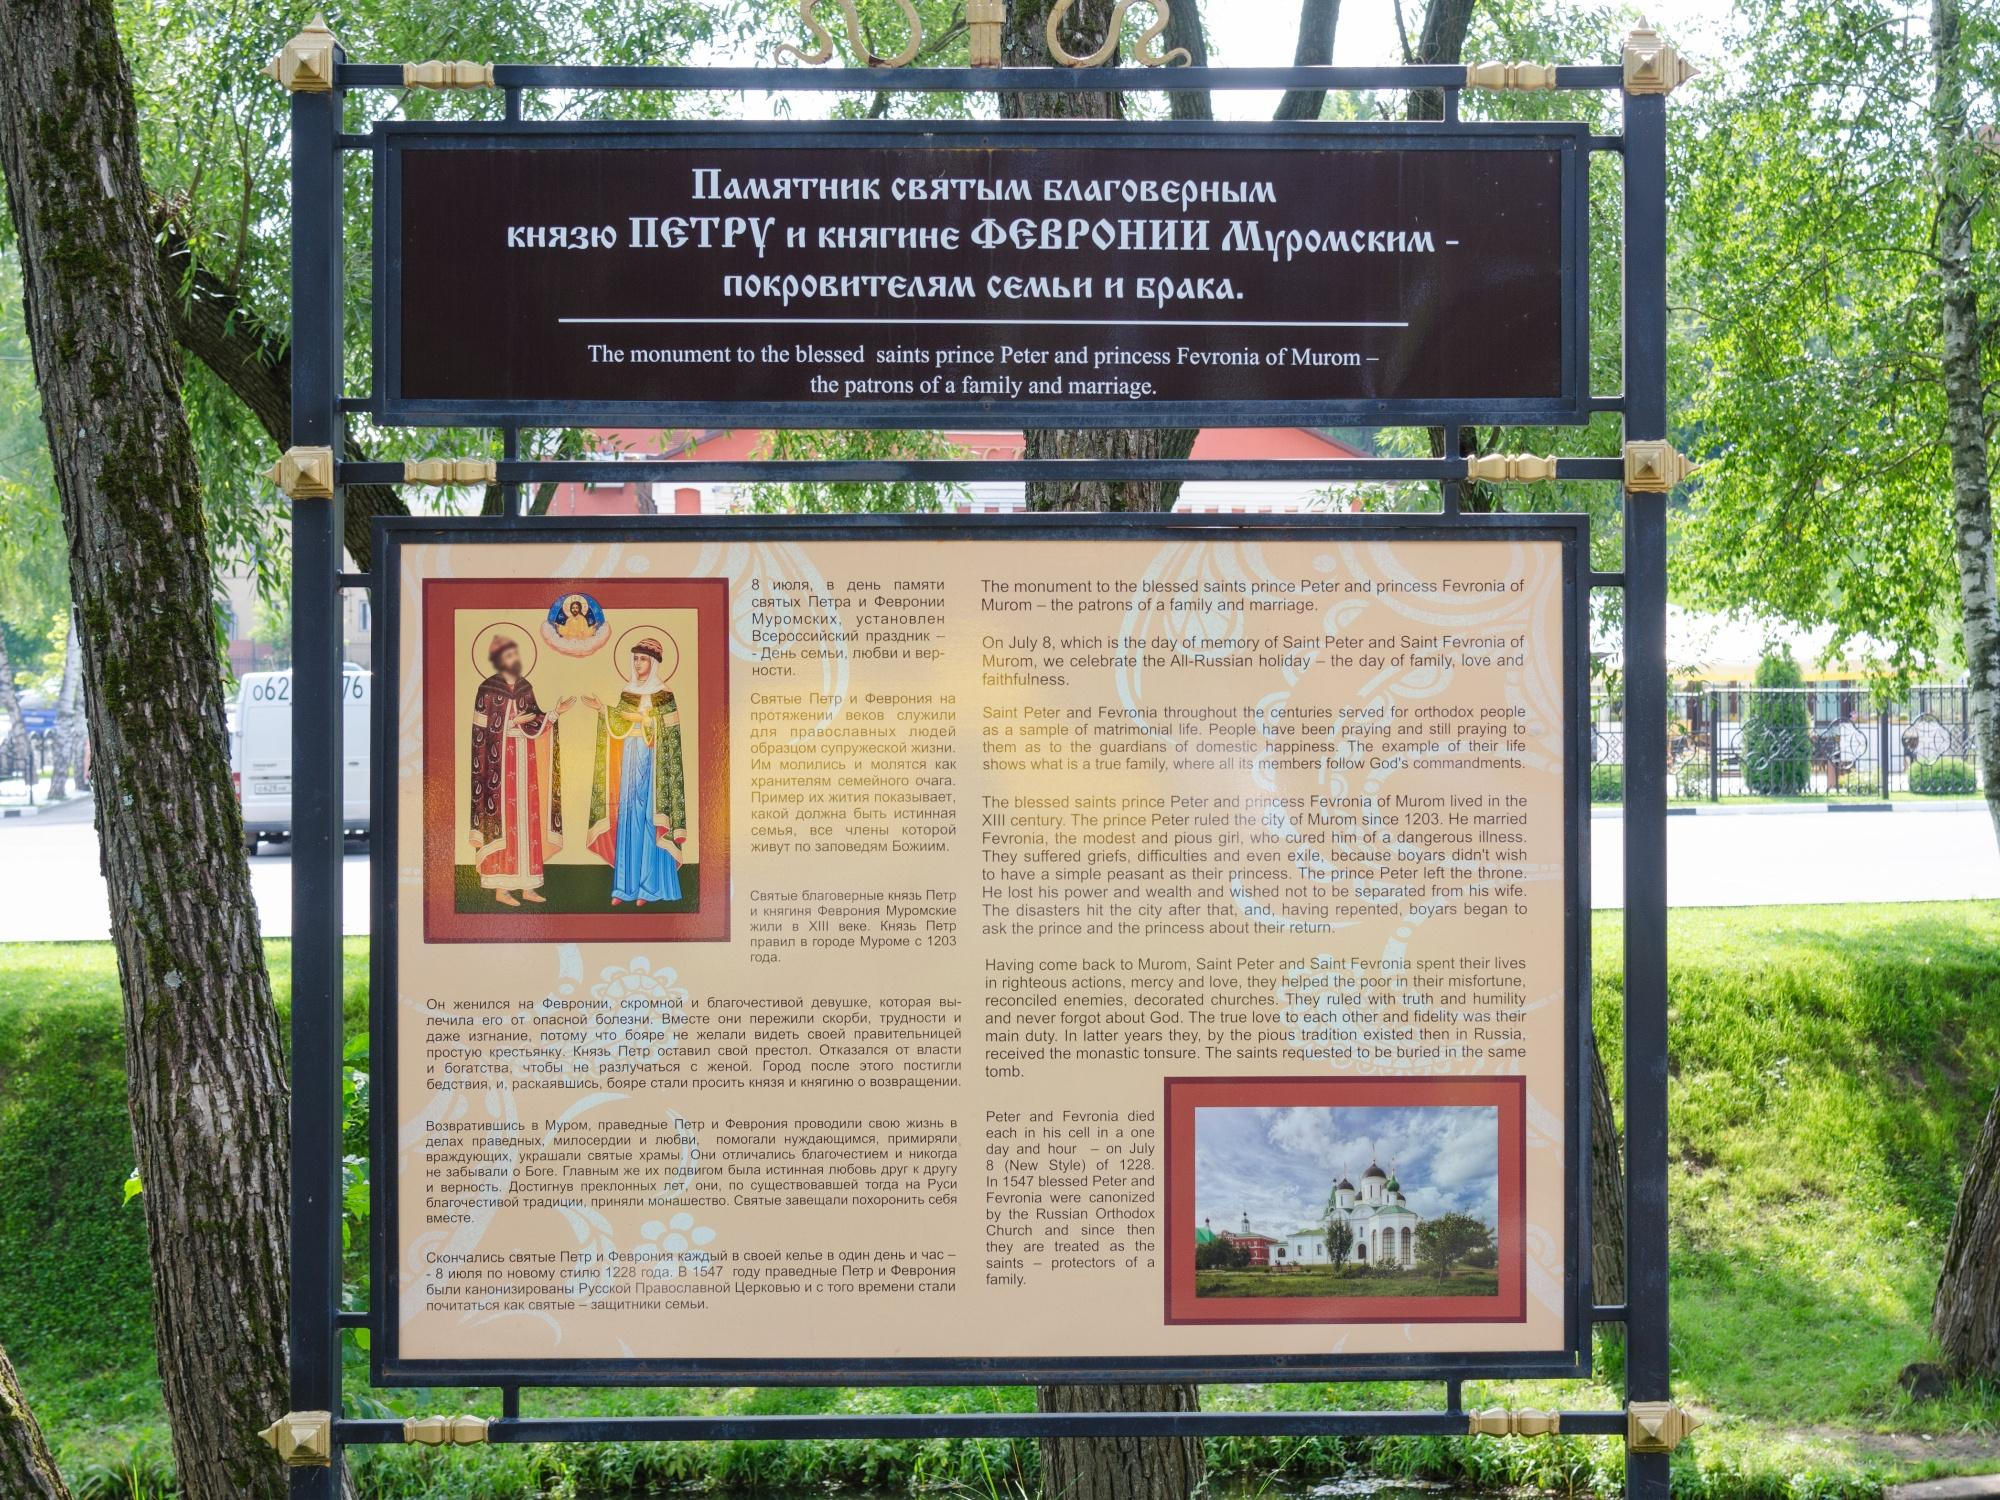What is this photo about? The photo depicts an informative signboard in a lush park setting, detailing the historical narrative of Prince Peter and Princess Fevronia of Murom, who are celebrated in Russian culture as patrons of family and marriage. The signboard, presented in a clear and visually appealing layout, is framed by green trees, underscoring its peaceful setting. This board not only contributes to the park's aesthetic but also serves an educational purpose, inviting visitors to delve into a pivotal piece of Russian heritage. 